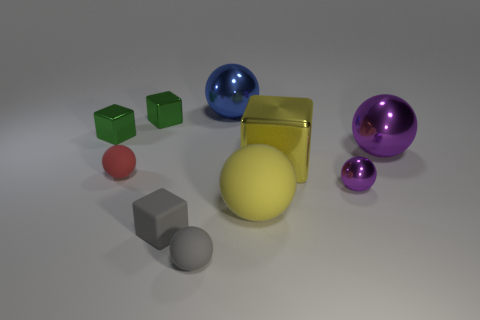How many things are either spheres that are left of the blue ball or things that are right of the big yellow matte thing?
Give a very brief answer. 5. There is a object that is in front of the tiny gray rubber block; is it the same shape as the small metallic thing that is on the right side of the big blue metallic thing?
Your response must be concise. Yes. There is a purple object that is the same size as the matte cube; what is its shape?
Offer a terse response. Sphere. What number of shiny things are either small cubes or tiny red balls?
Ensure brevity in your answer.  2. Do the large ball in front of the big purple thing and the cube on the right side of the gray cube have the same material?
Keep it short and to the point. No. There is another large sphere that is made of the same material as the gray ball; what color is it?
Give a very brief answer. Yellow. Are there more purple balls behind the big cube than gray balls behind the tiny red ball?
Offer a very short reply. Yes. Are there any green cubes?
Provide a short and direct response. Yes. What material is the block that is the same color as the big rubber ball?
Ensure brevity in your answer.  Metal. How many objects are tiny cyan shiny things or small rubber things?
Your answer should be compact. 3. 